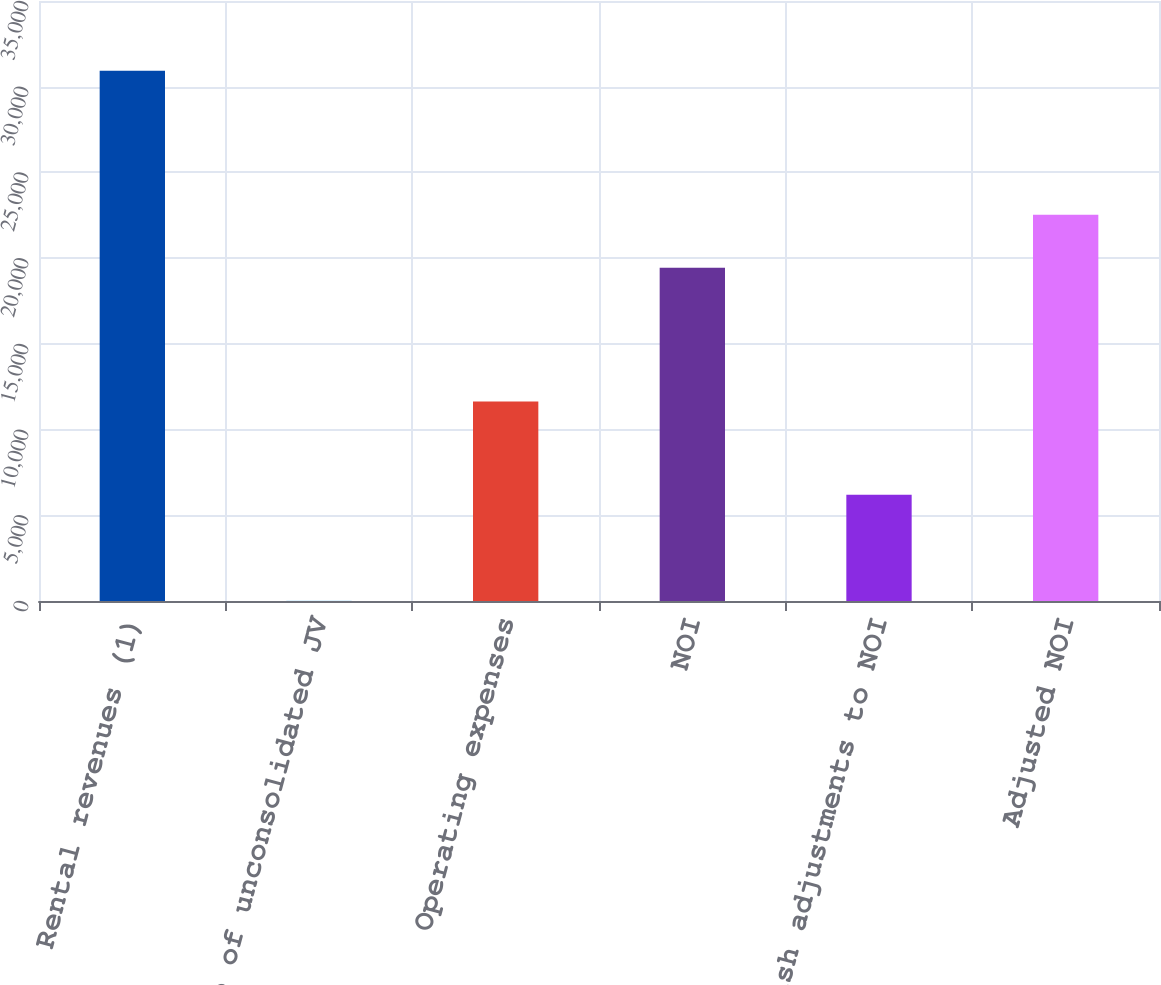Convert chart to OTSL. <chart><loc_0><loc_0><loc_500><loc_500><bar_chart><fcel>Rental revenues (1)<fcel>HCP share of unconsolidated JV<fcel>Operating expenses<fcel>NOI<fcel>Non-cash adjustments to NOI<fcel>Adjusted NOI<nl><fcel>30929<fcel>17<fcel>11633<fcel>19439<fcel>6199.4<fcel>22530.2<nl></chart> 